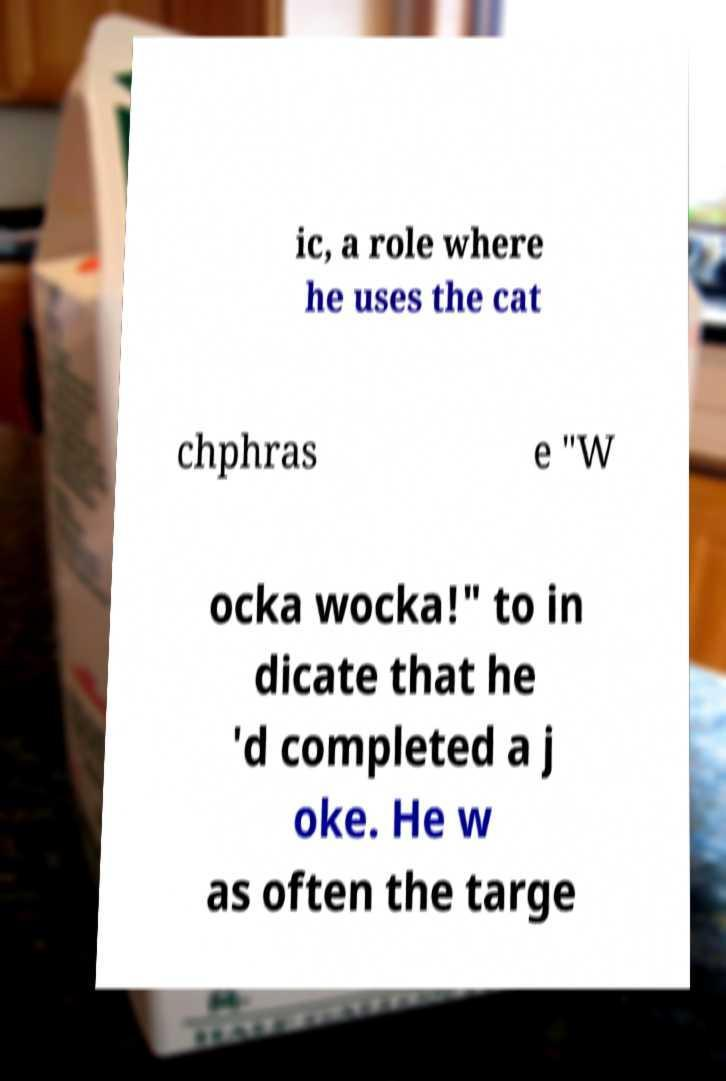For documentation purposes, I need the text within this image transcribed. Could you provide that? ic, a role where he uses the cat chphras e "W ocka wocka!" to in dicate that he 'd completed a j oke. He w as often the targe 